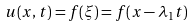Convert formula to latex. <formula><loc_0><loc_0><loc_500><loc_500>u ( x , t ) = f ( \xi ) = f ( x - \lambda _ { 1 } t )</formula> 